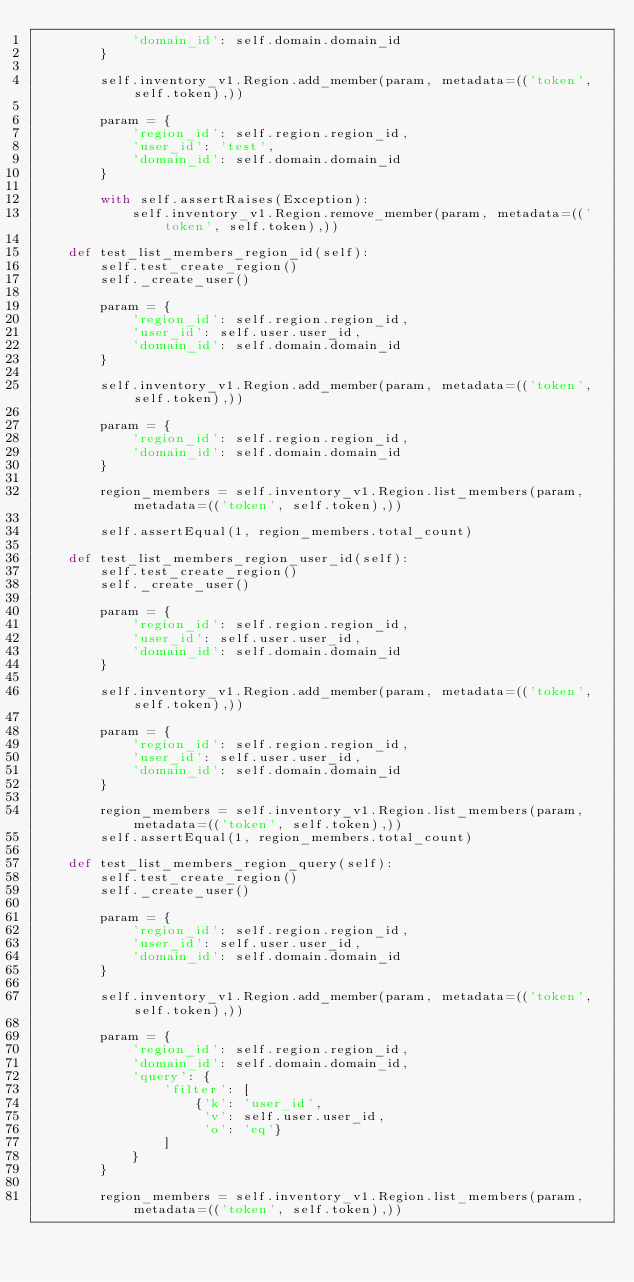Convert code to text. <code><loc_0><loc_0><loc_500><loc_500><_Python_>            'domain_id': self.domain.domain_id
        }

        self.inventory_v1.Region.add_member(param, metadata=(('token', self.token),))

        param = {
            'region_id': self.region.region_id,
            'user_id': 'test',
            'domain_id': self.domain.domain_id
        }

        with self.assertRaises(Exception):
            self.inventory_v1.Region.remove_member(param, metadata=(('token', self.token),))

    def test_list_members_region_id(self):
        self.test_create_region()
        self._create_user()

        param = {
            'region_id': self.region.region_id,
            'user_id': self.user.user_id,
            'domain_id': self.domain.domain_id
        }

        self.inventory_v1.Region.add_member(param, metadata=(('token', self.token),))

        param = {
            'region_id': self.region.region_id,
            'domain_id': self.domain.domain_id
        }

        region_members = self.inventory_v1.Region.list_members(param, metadata=(('token', self.token),))

        self.assertEqual(1, region_members.total_count)

    def test_list_members_region_user_id(self):
        self.test_create_region()
        self._create_user()

        param = {
            'region_id': self.region.region_id,
            'user_id': self.user.user_id,
            'domain_id': self.domain.domain_id
        }

        self.inventory_v1.Region.add_member(param, metadata=(('token', self.token),))

        param = {
            'region_id': self.region.region_id,
            'user_id': self.user.user_id,
            'domain_id': self.domain.domain_id
        }

        region_members = self.inventory_v1.Region.list_members(param, metadata=(('token', self.token),))
        self.assertEqual(1, region_members.total_count)

    def test_list_members_region_query(self):
        self.test_create_region()
        self._create_user()

        param = {
            'region_id': self.region.region_id,
            'user_id': self.user.user_id,
            'domain_id': self.domain.domain_id
        }

        self.inventory_v1.Region.add_member(param, metadata=(('token', self.token),))

        param = {
            'region_id': self.region.region_id,
            'domain_id': self.domain.domain_id,
            'query': {
                'filter': [
                    {'k': 'user_id',
                     'v': self.user.user_id,
                     'o': 'eq'}
                ]
            }
        }

        region_members = self.inventory_v1.Region.list_members(param, metadata=(('token', self.token),))</code> 